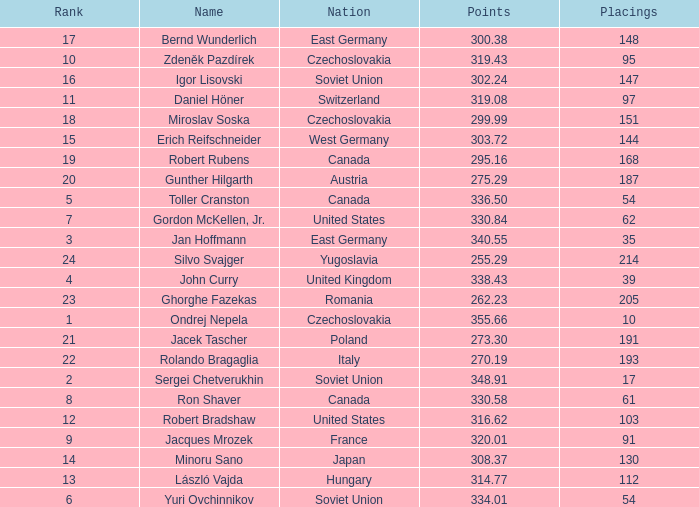Give me the full table as a dictionary. {'header': ['Rank', 'Name', 'Nation', 'Points', 'Placings'], 'rows': [['17', 'Bernd Wunderlich', 'East Germany', '300.38', '148'], ['10', 'Zdeněk Pazdírek', 'Czechoslovakia', '319.43', '95'], ['16', 'Igor Lisovski', 'Soviet Union', '302.24', '147'], ['11', 'Daniel Höner', 'Switzerland', '319.08', '97'], ['18', 'Miroslav Soska', 'Czechoslovakia', '299.99', '151'], ['15', 'Erich Reifschneider', 'West Germany', '303.72', '144'], ['19', 'Robert Rubens', 'Canada', '295.16', '168'], ['20', 'Gunther Hilgarth', 'Austria', '275.29', '187'], ['5', 'Toller Cranston', 'Canada', '336.50', '54'], ['7', 'Gordon McKellen, Jr.', 'United States', '330.84', '62'], ['3', 'Jan Hoffmann', 'East Germany', '340.55', '35'], ['24', 'Silvo Svajger', 'Yugoslavia', '255.29', '214'], ['4', 'John Curry', 'United Kingdom', '338.43', '39'], ['23', 'Ghorghe Fazekas', 'Romania', '262.23', '205'], ['1', 'Ondrej Nepela', 'Czechoslovakia', '355.66', '10'], ['21', 'Jacek Tascher', 'Poland', '273.30', '191'], ['22', 'Rolando Bragaglia', 'Italy', '270.19', '193'], ['2', 'Sergei Chetverukhin', 'Soviet Union', '348.91', '17'], ['8', 'Ron Shaver', 'Canada', '330.58', '61'], ['12', 'Robert Bradshaw', 'United States', '316.62', '103'], ['9', 'Jacques Mrozek', 'France', '320.01', '91'], ['14', 'Minoru Sano', 'Japan', '308.37', '130'], ['13', 'László Vajda', 'Hungary', '314.77', '112'], ['6', 'Yuri Ovchinnikov', 'Soviet Union', '334.01', '54']]} How many Placings have Points smaller than 330.84, and a Name of silvo svajger? 1.0. 